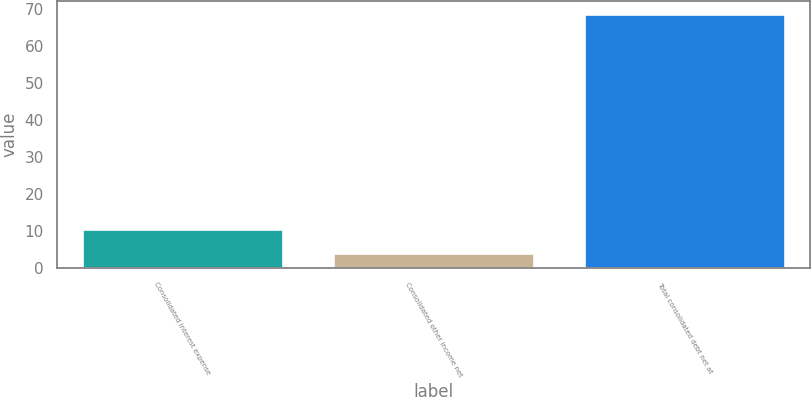Convert chart. <chart><loc_0><loc_0><loc_500><loc_500><bar_chart><fcel>Consolidated interest expense<fcel>Consolidated other income net<fcel>Total consolidated debt net at<nl><fcel>10.7<fcel>4.1<fcel>68.8<nl></chart> 